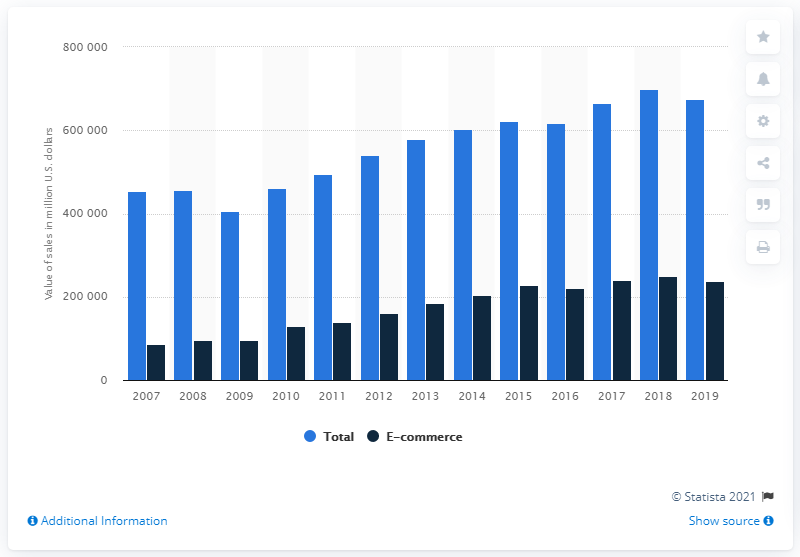Draw attention to some important aspects in this diagram. The e-commerce sales value in the most recent year was 238,981. In 2018, the value of e-commerce sales was approximately 250,517. 